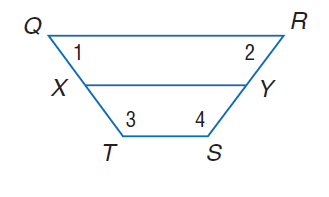Answer the mathemtical geometry problem and directly provide the correct option letter.
Question: Q R S T is an isosceles trapezoid with median X Y. Find T S if Q R = 22 and X Y = 15.
Choices: A: 2 B: 4 C: 8 D: 16 C 